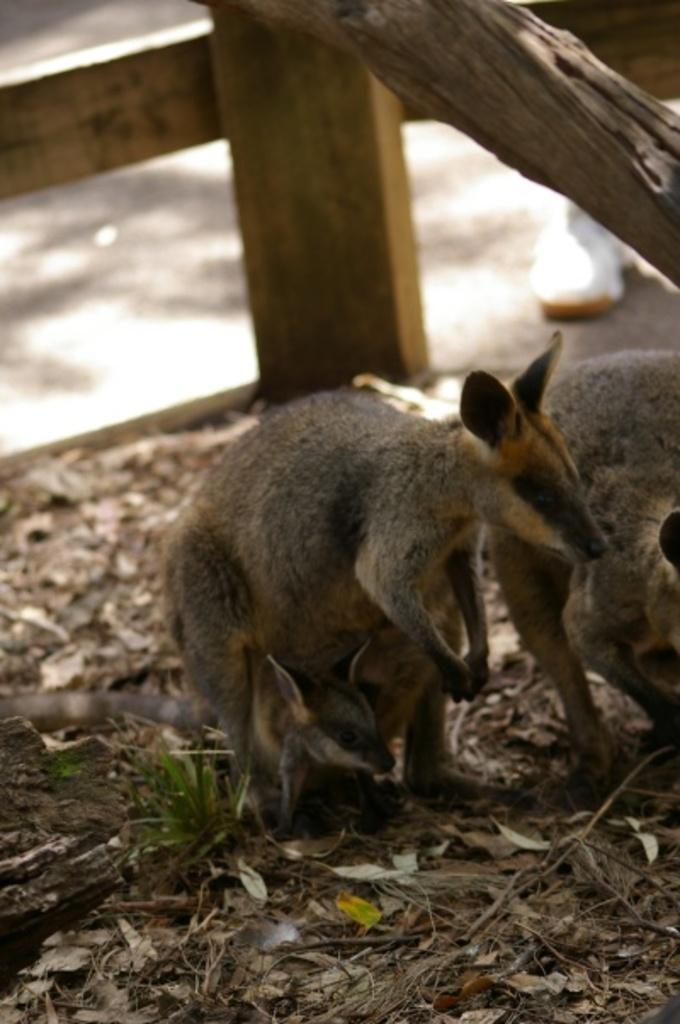What types of living organisms can be seen in the image? There are animals in the image. What can be found on the ground in the image? Dried leaves are present on the ground in the image. What type of material is used for some objects in the image? There are wooden objects in the image. Can you describe something visible in the background of the image? There is a shoe visible in the background of the image. What is the title of the book the frog is reading in the image? There is no frog or book present in the image. 